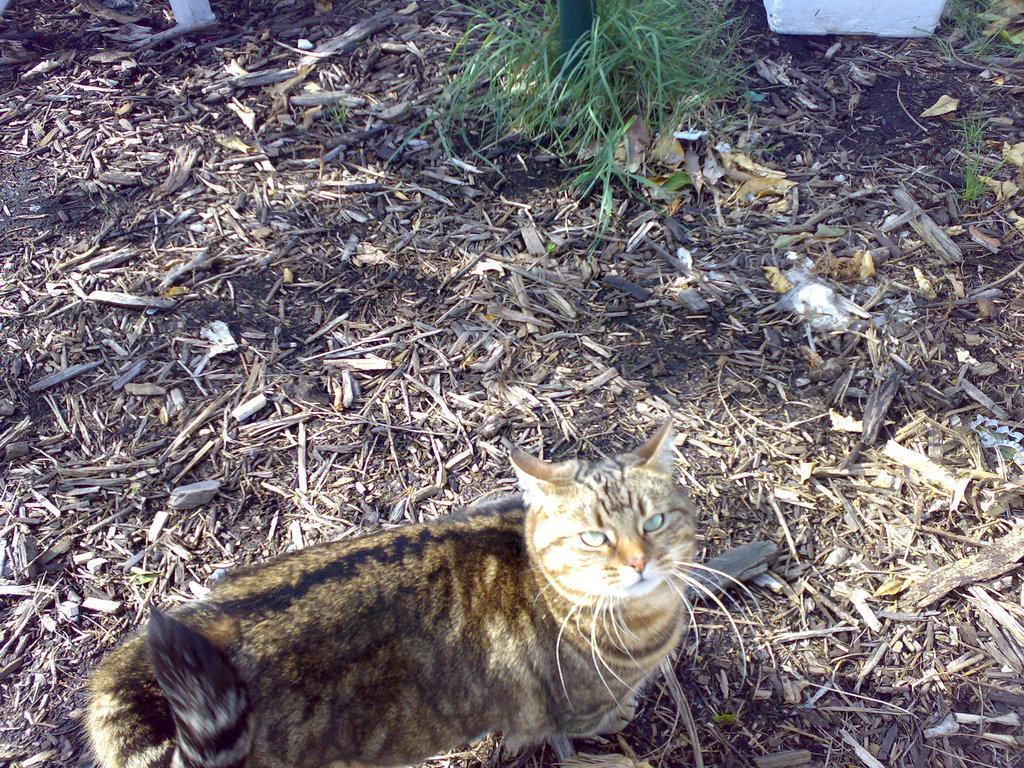Please provide a concise description of this image. At the bottom of the picture, we see the cat and it is looking at the camera. In the background, we see the twigs. At the top, we see the grass and an object in white color. 